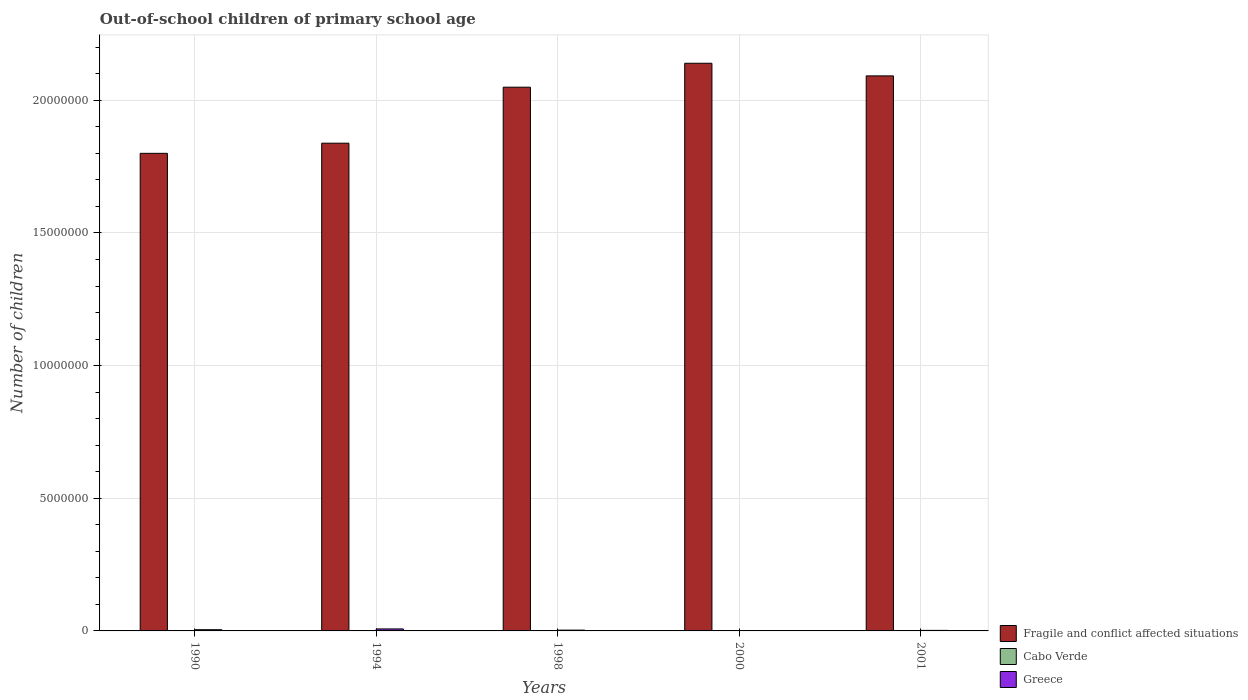How many different coloured bars are there?
Offer a very short reply. 3. Are the number of bars per tick equal to the number of legend labels?
Your response must be concise. Yes. Are the number of bars on each tick of the X-axis equal?
Offer a very short reply. Yes. How many bars are there on the 2nd tick from the left?
Ensure brevity in your answer.  3. How many bars are there on the 1st tick from the right?
Make the answer very short. 3. What is the label of the 1st group of bars from the left?
Your answer should be compact. 1990. What is the number of out-of-school children in Fragile and conflict affected situations in 2000?
Offer a very short reply. 2.14e+07. Across all years, what is the maximum number of out-of-school children in Cabo Verde?
Provide a short and direct response. 1038. Across all years, what is the minimum number of out-of-school children in Cabo Verde?
Keep it short and to the point. 381. In which year was the number of out-of-school children in Cabo Verde maximum?
Provide a succinct answer. 1990. What is the total number of out-of-school children in Cabo Verde in the graph?
Your answer should be compact. 3573. What is the difference between the number of out-of-school children in Cabo Verde in 1990 and that in 1998?
Make the answer very short. 293. What is the difference between the number of out-of-school children in Fragile and conflict affected situations in 1998 and the number of out-of-school children in Greece in 1990?
Offer a terse response. 2.04e+07. What is the average number of out-of-school children in Greece per year?
Give a very brief answer. 3.74e+04. In the year 2001, what is the difference between the number of out-of-school children in Fragile and conflict affected situations and number of out-of-school children in Cabo Verde?
Ensure brevity in your answer.  2.09e+07. In how many years, is the number of out-of-school children in Fragile and conflict affected situations greater than 4000000?
Offer a terse response. 5. What is the ratio of the number of out-of-school children in Greece in 1994 to that in 1998?
Keep it short and to the point. 2.5. Is the difference between the number of out-of-school children in Fragile and conflict affected situations in 1990 and 2001 greater than the difference between the number of out-of-school children in Cabo Verde in 1990 and 2001?
Ensure brevity in your answer.  No. What is the difference between the highest and the second highest number of out-of-school children in Greece?
Make the answer very short. 2.93e+04. What is the difference between the highest and the lowest number of out-of-school children in Greece?
Your response must be concise. 5.94e+04. Is the sum of the number of out-of-school children in Fragile and conflict affected situations in 2000 and 2001 greater than the maximum number of out-of-school children in Cabo Verde across all years?
Your answer should be compact. Yes. What does the 3rd bar from the left in 1998 represents?
Make the answer very short. Greece. What does the 1st bar from the right in 1990 represents?
Ensure brevity in your answer.  Greece. Is it the case that in every year, the sum of the number of out-of-school children in Fragile and conflict affected situations and number of out-of-school children in Cabo Verde is greater than the number of out-of-school children in Greece?
Your response must be concise. Yes. How many years are there in the graph?
Provide a short and direct response. 5. What is the difference between two consecutive major ticks on the Y-axis?
Ensure brevity in your answer.  5.00e+06. Are the values on the major ticks of Y-axis written in scientific E-notation?
Your answer should be compact. No. Does the graph contain grids?
Make the answer very short. Yes. How many legend labels are there?
Offer a very short reply. 3. How are the legend labels stacked?
Offer a terse response. Vertical. What is the title of the graph?
Make the answer very short. Out-of-school children of primary school age. Does "Djibouti" appear as one of the legend labels in the graph?
Ensure brevity in your answer.  No. What is the label or title of the Y-axis?
Offer a terse response. Number of children. What is the Number of children of Fragile and conflict affected situations in 1990?
Offer a very short reply. 1.80e+07. What is the Number of children in Cabo Verde in 1990?
Provide a short and direct response. 1038. What is the Number of children in Greece in 1990?
Your answer should be very brief. 4.59e+04. What is the Number of children in Fragile and conflict affected situations in 1994?
Offer a terse response. 1.84e+07. What is the Number of children in Cabo Verde in 1994?
Ensure brevity in your answer.  608. What is the Number of children of Greece in 1994?
Provide a succinct answer. 7.52e+04. What is the Number of children of Fragile and conflict affected situations in 1998?
Make the answer very short. 2.05e+07. What is the Number of children in Cabo Verde in 1998?
Keep it short and to the point. 745. What is the Number of children in Greece in 1998?
Make the answer very short. 3.00e+04. What is the Number of children in Fragile and conflict affected situations in 2000?
Give a very brief answer. 2.14e+07. What is the Number of children in Cabo Verde in 2000?
Provide a short and direct response. 381. What is the Number of children of Greece in 2000?
Your answer should be compact. 1.57e+04. What is the Number of children of Fragile and conflict affected situations in 2001?
Your answer should be very brief. 2.09e+07. What is the Number of children in Cabo Verde in 2001?
Your answer should be very brief. 801. What is the Number of children of Greece in 2001?
Provide a short and direct response. 2.03e+04. Across all years, what is the maximum Number of children in Fragile and conflict affected situations?
Ensure brevity in your answer.  2.14e+07. Across all years, what is the maximum Number of children in Cabo Verde?
Your answer should be very brief. 1038. Across all years, what is the maximum Number of children of Greece?
Keep it short and to the point. 7.52e+04. Across all years, what is the minimum Number of children of Fragile and conflict affected situations?
Make the answer very short. 1.80e+07. Across all years, what is the minimum Number of children in Cabo Verde?
Your answer should be compact. 381. Across all years, what is the minimum Number of children of Greece?
Your answer should be very brief. 1.57e+04. What is the total Number of children of Fragile and conflict affected situations in the graph?
Make the answer very short. 9.92e+07. What is the total Number of children of Cabo Verde in the graph?
Provide a short and direct response. 3573. What is the total Number of children of Greece in the graph?
Offer a terse response. 1.87e+05. What is the difference between the Number of children of Fragile and conflict affected situations in 1990 and that in 1994?
Offer a terse response. -3.82e+05. What is the difference between the Number of children of Cabo Verde in 1990 and that in 1994?
Make the answer very short. 430. What is the difference between the Number of children of Greece in 1990 and that in 1994?
Make the answer very short. -2.93e+04. What is the difference between the Number of children in Fragile and conflict affected situations in 1990 and that in 1998?
Provide a short and direct response. -2.49e+06. What is the difference between the Number of children of Cabo Verde in 1990 and that in 1998?
Make the answer very short. 293. What is the difference between the Number of children in Greece in 1990 and that in 1998?
Provide a succinct answer. 1.59e+04. What is the difference between the Number of children of Fragile and conflict affected situations in 1990 and that in 2000?
Offer a very short reply. -3.40e+06. What is the difference between the Number of children of Cabo Verde in 1990 and that in 2000?
Give a very brief answer. 657. What is the difference between the Number of children of Greece in 1990 and that in 2000?
Ensure brevity in your answer.  3.02e+04. What is the difference between the Number of children in Fragile and conflict affected situations in 1990 and that in 2001?
Your answer should be very brief. -2.92e+06. What is the difference between the Number of children of Cabo Verde in 1990 and that in 2001?
Give a very brief answer. 237. What is the difference between the Number of children of Greece in 1990 and that in 2001?
Make the answer very short. 2.56e+04. What is the difference between the Number of children of Fragile and conflict affected situations in 1994 and that in 1998?
Ensure brevity in your answer.  -2.11e+06. What is the difference between the Number of children of Cabo Verde in 1994 and that in 1998?
Keep it short and to the point. -137. What is the difference between the Number of children in Greece in 1994 and that in 1998?
Your answer should be very brief. 4.51e+04. What is the difference between the Number of children of Fragile and conflict affected situations in 1994 and that in 2000?
Ensure brevity in your answer.  -3.01e+06. What is the difference between the Number of children in Cabo Verde in 1994 and that in 2000?
Give a very brief answer. 227. What is the difference between the Number of children in Greece in 1994 and that in 2000?
Give a very brief answer. 5.94e+04. What is the difference between the Number of children in Fragile and conflict affected situations in 1994 and that in 2001?
Give a very brief answer. -2.54e+06. What is the difference between the Number of children of Cabo Verde in 1994 and that in 2001?
Ensure brevity in your answer.  -193. What is the difference between the Number of children in Greece in 1994 and that in 2001?
Provide a succinct answer. 5.49e+04. What is the difference between the Number of children of Fragile and conflict affected situations in 1998 and that in 2000?
Give a very brief answer. -9.02e+05. What is the difference between the Number of children in Cabo Verde in 1998 and that in 2000?
Provide a short and direct response. 364. What is the difference between the Number of children of Greece in 1998 and that in 2000?
Provide a succinct answer. 1.43e+04. What is the difference between the Number of children of Fragile and conflict affected situations in 1998 and that in 2001?
Offer a terse response. -4.26e+05. What is the difference between the Number of children in Cabo Verde in 1998 and that in 2001?
Keep it short and to the point. -56. What is the difference between the Number of children of Greece in 1998 and that in 2001?
Keep it short and to the point. 9770. What is the difference between the Number of children in Fragile and conflict affected situations in 2000 and that in 2001?
Give a very brief answer. 4.76e+05. What is the difference between the Number of children of Cabo Verde in 2000 and that in 2001?
Your answer should be very brief. -420. What is the difference between the Number of children in Greece in 2000 and that in 2001?
Offer a terse response. -4523. What is the difference between the Number of children in Fragile and conflict affected situations in 1990 and the Number of children in Cabo Verde in 1994?
Provide a short and direct response. 1.80e+07. What is the difference between the Number of children of Fragile and conflict affected situations in 1990 and the Number of children of Greece in 1994?
Make the answer very short. 1.79e+07. What is the difference between the Number of children in Cabo Verde in 1990 and the Number of children in Greece in 1994?
Keep it short and to the point. -7.41e+04. What is the difference between the Number of children in Fragile and conflict affected situations in 1990 and the Number of children in Cabo Verde in 1998?
Provide a short and direct response. 1.80e+07. What is the difference between the Number of children in Fragile and conflict affected situations in 1990 and the Number of children in Greece in 1998?
Make the answer very short. 1.80e+07. What is the difference between the Number of children of Cabo Verde in 1990 and the Number of children of Greece in 1998?
Make the answer very short. -2.90e+04. What is the difference between the Number of children of Fragile and conflict affected situations in 1990 and the Number of children of Cabo Verde in 2000?
Provide a succinct answer. 1.80e+07. What is the difference between the Number of children in Fragile and conflict affected situations in 1990 and the Number of children in Greece in 2000?
Ensure brevity in your answer.  1.80e+07. What is the difference between the Number of children of Cabo Verde in 1990 and the Number of children of Greece in 2000?
Offer a very short reply. -1.47e+04. What is the difference between the Number of children in Fragile and conflict affected situations in 1990 and the Number of children in Cabo Verde in 2001?
Ensure brevity in your answer.  1.80e+07. What is the difference between the Number of children of Fragile and conflict affected situations in 1990 and the Number of children of Greece in 2001?
Your response must be concise. 1.80e+07. What is the difference between the Number of children of Cabo Verde in 1990 and the Number of children of Greece in 2001?
Provide a succinct answer. -1.92e+04. What is the difference between the Number of children of Fragile and conflict affected situations in 1994 and the Number of children of Cabo Verde in 1998?
Keep it short and to the point. 1.84e+07. What is the difference between the Number of children of Fragile and conflict affected situations in 1994 and the Number of children of Greece in 1998?
Provide a short and direct response. 1.84e+07. What is the difference between the Number of children in Cabo Verde in 1994 and the Number of children in Greece in 1998?
Make the answer very short. -2.94e+04. What is the difference between the Number of children in Fragile and conflict affected situations in 1994 and the Number of children in Cabo Verde in 2000?
Your answer should be compact. 1.84e+07. What is the difference between the Number of children in Fragile and conflict affected situations in 1994 and the Number of children in Greece in 2000?
Ensure brevity in your answer.  1.84e+07. What is the difference between the Number of children of Cabo Verde in 1994 and the Number of children of Greece in 2000?
Make the answer very short. -1.51e+04. What is the difference between the Number of children of Fragile and conflict affected situations in 1994 and the Number of children of Cabo Verde in 2001?
Keep it short and to the point. 1.84e+07. What is the difference between the Number of children in Fragile and conflict affected situations in 1994 and the Number of children in Greece in 2001?
Your response must be concise. 1.84e+07. What is the difference between the Number of children of Cabo Verde in 1994 and the Number of children of Greece in 2001?
Give a very brief answer. -1.97e+04. What is the difference between the Number of children of Fragile and conflict affected situations in 1998 and the Number of children of Cabo Verde in 2000?
Give a very brief answer. 2.05e+07. What is the difference between the Number of children in Fragile and conflict affected situations in 1998 and the Number of children in Greece in 2000?
Offer a very short reply. 2.05e+07. What is the difference between the Number of children of Cabo Verde in 1998 and the Number of children of Greece in 2000?
Give a very brief answer. -1.50e+04. What is the difference between the Number of children of Fragile and conflict affected situations in 1998 and the Number of children of Cabo Verde in 2001?
Make the answer very short. 2.05e+07. What is the difference between the Number of children of Fragile and conflict affected situations in 1998 and the Number of children of Greece in 2001?
Make the answer very short. 2.05e+07. What is the difference between the Number of children in Cabo Verde in 1998 and the Number of children in Greece in 2001?
Ensure brevity in your answer.  -1.95e+04. What is the difference between the Number of children in Fragile and conflict affected situations in 2000 and the Number of children in Cabo Verde in 2001?
Keep it short and to the point. 2.14e+07. What is the difference between the Number of children in Fragile and conflict affected situations in 2000 and the Number of children in Greece in 2001?
Make the answer very short. 2.14e+07. What is the difference between the Number of children in Cabo Verde in 2000 and the Number of children in Greece in 2001?
Provide a short and direct response. -1.99e+04. What is the average Number of children of Fragile and conflict affected situations per year?
Provide a short and direct response. 1.98e+07. What is the average Number of children in Cabo Verde per year?
Offer a terse response. 714.6. What is the average Number of children of Greece per year?
Ensure brevity in your answer.  3.74e+04. In the year 1990, what is the difference between the Number of children of Fragile and conflict affected situations and Number of children of Cabo Verde?
Provide a short and direct response. 1.80e+07. In the year 1990, what is the difference between the Number of children of Fragile and conflict affected situations and Number of children of Greece?
Make the answer very short. 1.80e+07. In the year 1990, what is the difference between the Number of children of Cabo Verde and Number of children of Greece?
Keep it short and to the point. -4.49e+04. In the year 1994, what is the difference between the Number of children of Fragile and conflict affected situations and Number of children of Cabo Verde?
Your response must be concise. 1.84e+07. In the year 1994, what is the difference between the Number of children of Fragile and conflict affected situations and Number of children of Greece?
Offer a very short reply. 1.83e+07. In the year 1994, what is the difference between the Number of children in Cabo Verde and Number of children in Greece?
Your answer should be very brief. -7.46e+04. In the year 1998, what is the difference between the Number of children of Fragile and conflict affected situations and Number of children of Cabo Verde?
Your answer should be compact. 2.05e+07. In the year 1998, what is the difference between the Number of children in Fragile and conflict affected situations and Number of children in Greece?
Offer a terse response. 2.05e+07. In the year 1998, what is the difference between the Number of children in Cabo Verde and Number of children in Greece?
Offer a terse response. -2.93e+04. In the year 2000, what is the difference between the Number of children of Fragile and conflict affected situations and Number of children of Cabo Verde?
Give a very brief answer. 2.14e+07. In the year 2000, what is the difference between the Number of children in Fragile and conflict affected situations and Number of children in Greece?
Your answer should be compact. 2.14e+07. In the year 2000, what is the difference between the Number of children of Cabo Verde and Number of children of Greece?
Your response must be concise. -1.54e+04. In the year 2001, what is the difference between the Number of children of Fragile and conflict affected situations and Number of children of Cabo Verde?
Ensure brevity in your answer.  2.09e+07. In the year 2001, what is the difference between the Number of children in Fragile and conflict affected situations and Number of children in Greece?
Offer a very short reply. 2.09e+07. In the year 2001, what is the difference between the Number of children in Cabo Verde and Number of children in Greece?
Ensure brevity in your answer.  -1.95e+04. What is the ratio of the Number of children in Fragile and conflict affected situations in 1990 to that in 1994?
Keep it short and to the point. 0.98. What is the ratio of the Number of children in Cabo Verde in 1990 to that in 1994?
Your answer should be very brief. 1.71. What is the ratio of the Number of children in Greece in 1990 to that in 1994?
Keep it short and to the point. 0.61. What is the ratio of the Number of children of Fragile and conflict affected situations in 1990 to that in 1998?
Offer a terse response. 0.88. What is the ratio of the Number of children of Cabo Verde in 1990 to that in 1998?
Your answer should be very brief. 1.39. What is the ratio of the Number of children of Greece in 1990 to that in 1998?
Your response must be concise. 1.53. What is the ratio of the Number of children in Fragile and conflict affected situations in 1990 to that in 2000?
Keep it short and to the point. 0.84. What is the ratio of the Number of children of Cabo Verde in 1990 to that in 2000?
Provide a short and direct response. 2.72. What is the ratio of the Number of children of Greece in 1990 to that in 2000?
Offer a very short reply. 2.92. What is the ratio of the Number of children in Fragile and conflict affected situations in 1990 to that in 2001?
Keep it short and to the point. 0.86. What is the ratio of the Number of children of Cabo Verde in 1990 to that in 2001?
Provide a succinct answer. 1.3. What is the ratio of the Number of children of Greece in 1990 to that in 2001?
Provide a succinct answer. 2.27. What is the ratio of the Number of children of Fragile and conflict affected situations in 1994 to that in 1998?
Your answer should be very brief. 0.9. What is the ratio of the Number of children in Cabo Verde in 1994 to that in 1998?
Keep it short and to the point. 0.82. What is the ratio of the Number of children in Greece in 1994 to that in 1998?
Keep it short and to the point. 2.5. What is the ratio of the Number of children of Fragile and conflict affected situations in 1994 to that in 2000?
Offer a terse response. 0.86. What is the ratio of the Number of children of Cabo Verde in 1994 to that in 2000?
Ensure brevity in your answer.  1.6. What is the ratio of the Number of children in Greece in 1994 to that in 2000?
Make the answer very short. 4.78. What is the ratio of the Number of children in Fragile and conflict affected situations in 1994 to that in 2001?
Offer a very short reply. 0.88. What is the ratio of the Number of children in Cabo Verde in 1994 to that in 2001?
Give a very brief answer. 0.76. What is the ratio of the Number of children of Greece in 1994 to that in 2001?
Provide a succinct answer. 3.71. What is the ratio of the Number of children in Fragile and conflict affected situations in 1998 to that in 2000?
Your response must be concise. 0.96. What is the ratio of the Number of children in Cabo Verde in 1998 to that in 2000?
Keep it short and to the point. 1.96. What is the ratio of the Number of children of Greece in 1998 to that in 2000?
Your answer should be compact. 1.91. What is the ratio of the Number of children of Fragile and conflict affected situations in 1998 to that in 2001?
Ensure brevity in your answer.  0.98. What is the ratio of the Number of children of Cabo Verde in 1998 to that in 2001?
Give a very brief answer. 0.93. What is the ratio of the Number of children in Greece in 1998 to that in 2001?
Your answer should be very brief. 1.48. What is the ratio of the Number of children in Fragile and conflict affected situations in 2000 to that in 2001?
Your response must be concise. 1.02. What is the ratio of the Number of children in Cabo Verde in 2000 to that in 2001?
Give a very brief answer. 0.48. What is the ratio of the Number of children of Greece in 2000 to that in 2001?
Provide a succinct answer. 0.78. What is the difference between the highest and the second highest Number of children in Fragile and conflict affected situations?
Keep it short and to the point. 4.76e+05. What is the difference between the highest and the second highest Number of children in Cabo Verde?
Offer a very short reply. 237. What is the difference between the highest and the second highest Number of children in Greece?
Keep it short and to the point. 2.93e+04. What is the difference between the highest and the lowest Number of children in Fragile and conflict affected situations?
Keep it short and to the point. 3.40e+06. What is the difference between the highest and the lowest Number of children in Cabo Verde?
Make the answer very short. 657. What is the difference between the highest and the lowest Number of children of Greece?
Your response must be concise. 5.94e+04. 